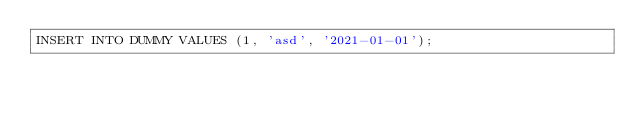Convert code to text. <code><loc_0><loc_0><loc_500><loc_500><_SQL_>INSERT INTO DUMMY VALUES (1, 'asd', '2021-01-01');
</code> 